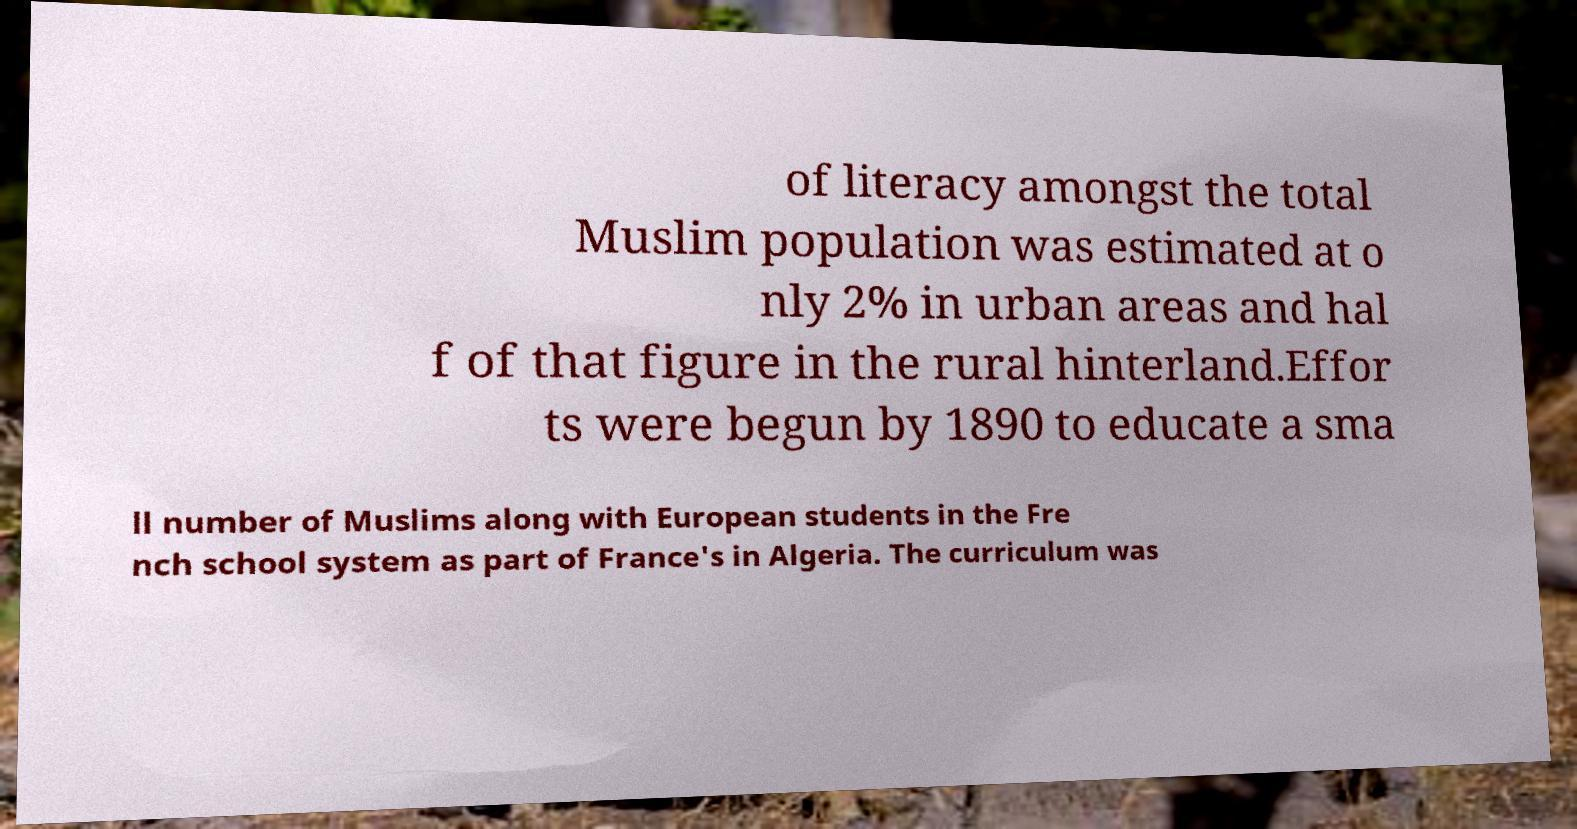Could you extract and type out the text from this image? of literacy amongst the total Muslim population was estimated at o nly 2% in urban areas and hal f of that figure in the rural hinterland.Effor ts were begun by 1890 to educate a sma ll number of Muslims along with European students in the Fre nch school system as part of France's in Algeria. The curriculum was 